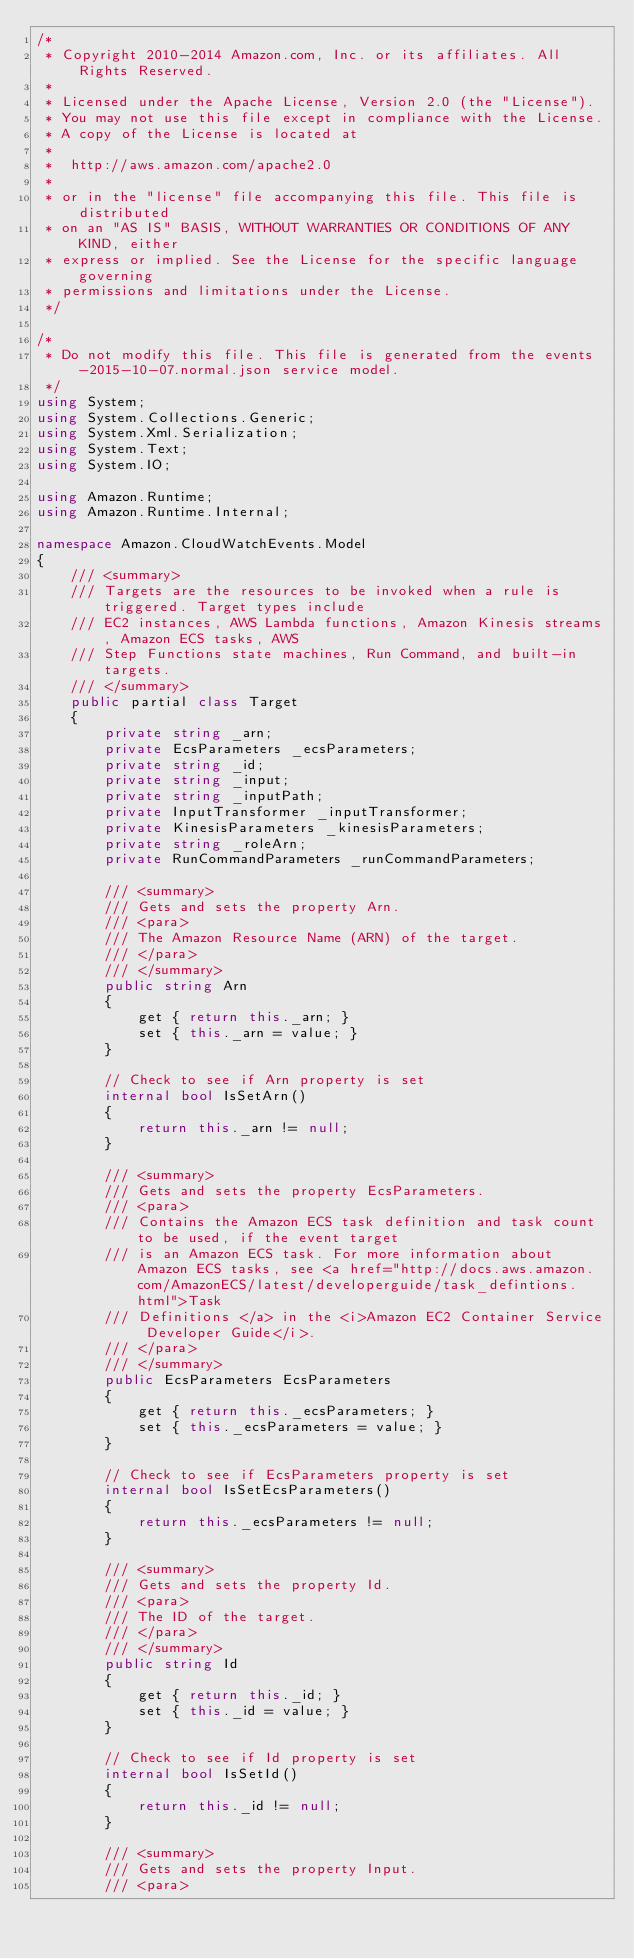<code> <loc_0><loc_0><loc_500><loc_500><_C#_>/*
 * Copyright 2010-2014 Amazon.com, Inc. or its affiliates. All Rights Reserved.
 * 
 * Licensed under the Apache License, Version 2.0 (the "License").
 * You may not use this file except in compliance with the License.
 * A copy of the License is located at
 * 
 *  http://aws.amazon.com/apache2.0
 * 
 * or in the "license" file accompanying this file. This file is distributed
 * on an "AS IS" BASIS, WITHOUT WARRANTIES OR CONDITIONS OF ANY KIND, either
 * express or implied. See the License for the specific language governing
 * permissions and limitations under the License.
 */

/*
 * Do not modify this file. This file is generated from the events-2015-10-07.normal.json service model.
 */
using System;
using System.Collections.Generic;
using System.Xml.Serialization;
using System.Text;
using System.IO;

using Amazon.Runtime;
using Amazon.Runtime.Internal;

namespace Amazon.CloudWatchEvents.Model
{
    /// <summary>
    /// Targets are the resources to be invoked when a rule is triggered. Target types include
    /// EC2 instances, AWS Lambda functions, Amazon Kinesis streams, Amazon ECS tasks, AWS
    /// Step Functions state machines, Run Command, and built-in targets.
    /// </summary>
    public partial class Target
    {
        private string _arn;
        private EcsParameters _ecsParameters;
        private string _id;
        private string _input;
        private string _inputPath;
        private InputTransformer _inputTransformer;
        private KinesisParameters _kinesisParameters;
        private string _roleArn;
        private RunCommandParameters _runCommandParameters;

        /// <summary>
        /// Gets and sets the property Arn. 
        /// <para>
        /// The Amazon Resource Name (ARN) of the target.
        /// </para>
        /// </summary>
        public string Arn
        {
            get { return this._arn; }
            set { this._arn = value; }
        }

        // Check to see if Arn property is set
        internal bool IsSetArn()
        {
            return this._arn != null;
        }

        /// <summary>
        /// Gets and sets the property EcsParameters. 
        /// <para>
        /// Contains the Amazon ECS task definition and task count to be used, if the event target
        /// is an Amazon ECS task. For more information about Amazon ECS tasks, see <a href="http://docs.aws.amazon.com/AmazonECS/latest/developerguide/task_defintions.html">Task
        /// Definitions </a> in the <i>Amazon EC2 Container Service Developer Guide</i>.
        /// </para>
        /// </summary>
        public EcsParameters EcsParameters
        {
            get { return this._ecsParameters; }
            set { this._ecsParameters = value; }
        }

        // Check to see if EcsParameters property is set
        internal bool IsSetEcsParameters()
        {
            return this._ecsParameters != null;
        }

        /// <summary>
        /// Gets and sets the property Id. 
        /// <para>
        /// The ID of the target.
        /// </para>
        /// </summary>
        public string Id
        {
            get { return this._id; }
            set { this._id = value; }
        }

        // Check to see if Id property is set
        internal bool IsSetId()
        {
            return this._id != null;
        }

        /// <summary>
        /// Gets and sets the property Input. 
        /// <para></code> 